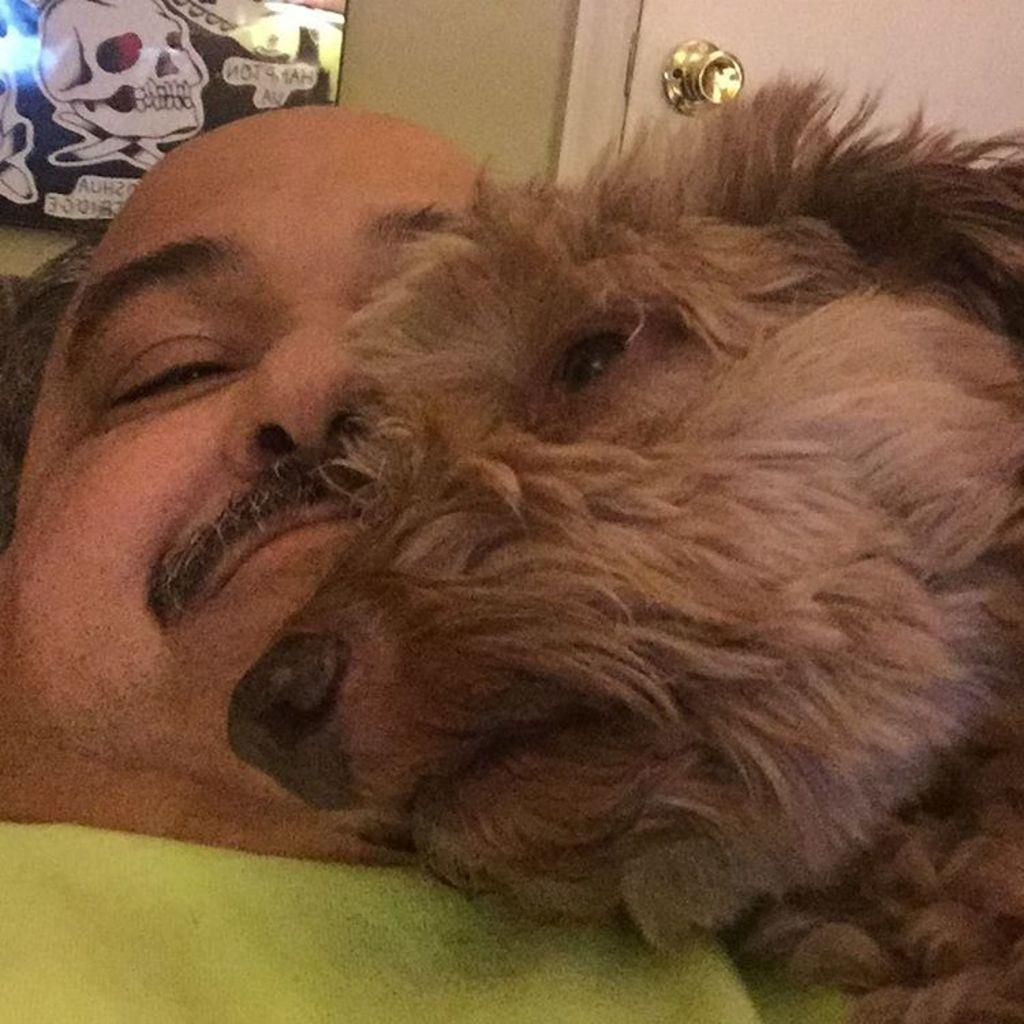What is the main subject in the image? There is a man in the image. Are there any animals present in the image? Yes, there is a dog in the image. What type of artwork can be seen in the image? There is a wall painting in the image. Can you describe any architectural features in the image? Yes, there is a door in the image. What type of mint can be seen growing near the door in the image? There is no mint present in the image. How does the robin interact with the dog in the image? There is no robin present in the image. 